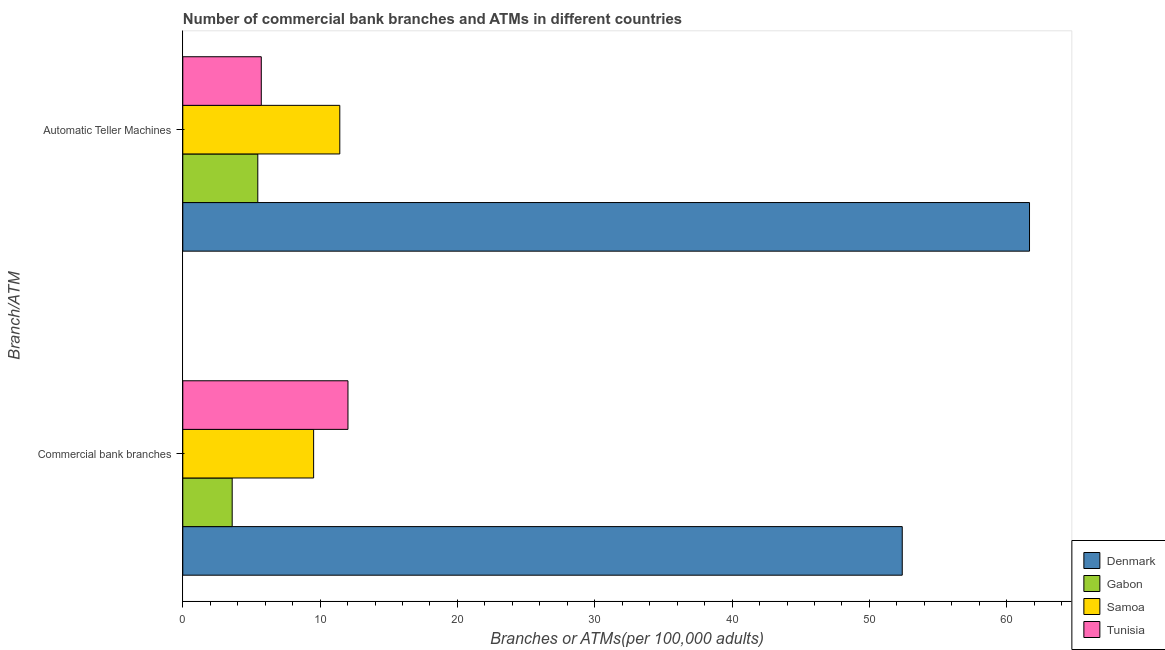How many groups of bars are there?
Provide a short and direct response. 2. How many bars are there on the 1st tick from the bottom?
Ensure brevity in your answer.  4. What is the label of the 1st group of bars from the top?
Your answer should be very brief. Automatic Teller Machines. What is the number of atms in Tunisia?
Your answer should be compact. 5.72. Across all countries, what is the maximum number of atms?
Ensure brevity in your answer.  61.66. Across all countries, what is the minimum number of commercal bank branches?
Provide a succinct answer. 3.6. In which country was the number of commercal bank branches maximum?
Ensure brevity in your answer.  Denmark. In which country was the number of atms minimum?
Offer a very short reply. Gabon. What is the total number of atms in the graph?
Your answer should be compact. 84.27. What is the difference between the number of commercal bank branches in Denmark and that in Samoa?
Provide a succinct answer. 42.86. What is the difference between the number of atms in Gabon and the number of commercal bank branches in Denmark?
Your answer should be compact. -46.93. What is the average number of atms per country?
Make the answer very short. 21.07. What is the difference between the number of atms and number of commercal bank branches in Denmark?
Offer a very short reply. 9.27. What is the ratio of the number of atms in Tunisia to that in Gabon?
Offer a very short reply. 1.05. Is the number of commercal bank branches in Tunisia less than that in Gabon?
Your answer should be very brief. No. What does the 1st bar from the bottom in Commercial bank branches represents?
Provide a succinct answer. Denmark. Are all the bars in the graph horizontal?
Ensure brevity in your answer.  Yes. How many countries are there in the graph?
Keep it short and to the point. 4. Where does the legend appear in the graph?
Ensure brevity in your answer.  Bottom right. How many legend labels are there?
Give a very brief answer. 4. What is the title of the graph?
Make the answer very short. Number of commercial bank branches and ATMs in different countries. What is the label or title of the X-axis?
Provide a short and direct response. Branches or ATMs(per 100,0 adults). What is the label or title of the Y-axis?
Provide a succinct answer. Branch/ATM. What is the Branches or ATMs(per 100,000 adults) in Denmark in Commercial bank branches?
Provide a succinct answer. 52.39. What is the Branches or ATMs(per 100,000 adults) in Gabon in Commercial bank branches?
Your response must be concise. 3.6. What is the Branches or ATMs(per 100,000 adults) of Samoa in Commercial bank branches?
Keep it short and to the point. 9.53. What is the Branches or ATMs(per 100,000 adults) in Tunisia in Commercial bank branches?
Your response must be concise. 12.03. What is the Branches or ATMs(per 100,000 adults) of Denmark in Automatic Teller Machines?
Your answer should be very brief. 61.66. What is the Branches or ATMs(per 100,000 adults) of Gabon in Automatic Teller Machines?
Give a very brief answer. 5.46. What is the Branches or ATMs(per 100,000 adults) in Samoa in Automatic Teller Machines?
Offer a terse response. 11.43. What is the Branches or ATMs(per 100,000 adults) in Tunisia in Automatic Teller Machines?
Ensure brevity in your answer.  5.72. Across all Branch/ATM, what is the maximum Branches or ATMs(per 100,000 adults) in Denmark?
Your response must be concise. 61.66. Across all Branch/ATM, what is the maximum Branches or ATMs(per 100,000 adults) in Gabon?
Offer a terse response. 5.46. Across all Branch/ATM, what is the maximum Branches or ATMs(per 100,000 adults) in Samoa?
Your response must be concise. 11.43. Across all Branch/ATM, what is the maximum Branches or ATMs(per 100,000 adults) in Tunisia?
Make the answer very short. 12.03. Across all Branch/ATM, what is the minimum Branches or ATMs(per 100,000 adults) of Denmark?
Make the answer very short. 52.39. Across all Branch/ATM, what is the minimum Branches or ATMs(per 100,000 adults) in Gabon?
Provide a succinct answer. 3.6. Across all Branch/ATM, what is the minimum Branches or ATMs(per 100,000 adults) in Samoa?
Keep it short and to the point. 9.53. Across all Branch/ATM, what is the minimum Branches or ATMs(per 100,000 adults) of Tunisia?
Provide a short and direct response. 5.72. What is the total Branches or ATMs(per 100,000 adults) in Denmark in the graph?
Keep it short and to the point. 114.05. What is the total Branches or ATMs(per 100,000 adults) of Gabon in the graph?
Make the answer very short. 9.06. What is the total Branches or ATMs(per 100,000 adults) in Samoa in the graph?
Offer a terse response. 20.96. What is the total Branches or ATMs(per 100,000 adults) in Tunisia in the graph?
Ensure brevity in your answer.  17.74. What is the difference between the Branches or ATMs(per 100,000 adults) of Denmark in Commercial bank branches and that in Automatic Teller Machines?
Keep it short and to the point. -9.27. What is the difference between the Branches or ATMs(per 100,000 adults) of Gabon in Commercial bank branches and that in Automatic Teller Machines?
Make the answer very short. -1.86. What is the difference between the Branches or ATMs(per 100,000 adults) in Samoa in Commercial bank branches and that in Automatic Teller Machines?
Offer a terse response. -1.91. What is the difference between the Branches or ATMs(per 100,000 adults) in Tunisia in Commercial bank branches and that in Automatic Teller Machines?
Provide a succinct answer. 6.31. What is the difference between the Branches or ATMs(per 100,000 adults) of Denmark in Commercial bank branches and the Branches or ATMs(per 100,000 adults) of Gabon in Automatic Teller Machines?
Ensure brevity in your answer.  46.93. What is the difference between the Branches or ATMs(per 100,000 adults) in Denmark in Commercial bank branches and the Branches or ATMs(per 100,000 adults) in Samoa in Automatic Teller Machines?
Ensure brevity in your answer.  40.96. What is the difference between the Branches or ATMs(per 100,000 adults) in Denmark in Commercial bank branches and the Branches or ATMs(per 100,000 adults) in Tunisia in Automatic Teller Machines?
Give a very brief answer. 46.68. What is the difference between the Branches or ATMs(per 100,000 adults) in Gabon in Commercial bank branches and the Branches or ATMs(per 100,000 adults) in Samoa in Automatic Teller Machines?
Provide a short and direct response. -7.84. What is the difference between the Branches or ATMs(per 100,000 adults) of Gabon in Commercial bank branches and the Branches or ATMs(per 100,000 adults) of Tunisia in Automatic Teller Machines?
Ensure brevity in your answer.  -2.12. What is the difference between the Branches or ATMs(per 100,000 adults) of Samoa in Commercial bank branches and the Branches or ATMs(per 100,000 adults) of Tunisia in Automatic Teller Machines?
Keep it short and to the point. 3.81. What is the average Branches or ATMs(per 100,000 adults) of Denmark per Branch/ATM?
Offer a very short reply. 57.02. What is the average Branches or ATMs(per 100,000 adults) in Gabon per Branch/ATM?
Provide a short and direct response. 4.53. What is the average Branches or ATMs(per 100,000 adults) in Samoa per Branch/ATM?
Offer a very short reply. 10.48. What is the average Branches or ATMs(per 100,000 adults) in Tunisia per Branch/ATM?
Your answer should be compact. 8.87. What is the difference between the Branches or ATMs(per 100,000 adults) in Denmark and Branches or ATMs(per 100,000 adults) in Gabon in Commercial bank branches?
Make the answer very short. 48.79. What is the difference between the Branches or ATMs(per 100,000 adults) in Denmark and Branches or ATMs(per 100,000 adults) in Samoa in Commercial bank branches?
Give a very brief answer. 42.86. What is the difference between the Branches or ATMs(per 100,000 adults) of Denmark and Branches or ATMs(per 100,000 adults) of Tunisia in Commercial bank branches?
Keep it short and to the point. 40.36. What is the difference between the Branches or ATMs(per 100,000 adults) of Gabon and Branches or ATMs(per 100,000 adults) of Samoa in Commercial bank branches?
Provide a short and direct response. -5.93. What is the difference between the Branches or ATMs(per 100,000 adults) of Gabon and Branches or ATMs(per 100,000 adults) of Tunisia in Commercial bank branches?
Your answer should be compact. -8.43. What is the difference between the Branches or ATMs(per 100,000 adults) in Samoa and Branches or ATMs(per 100,000 adults) in Tunisia in Commercial bank branches?
Offer a terse response. -2.5. What is the difference between the Branches or ATMs(per 100,000 adults) of Denmark and Branches or ATMs(per 100,000 adults) of Gabon in Automatic Teller Machines?
Offer a very short reply. 56.2. What is the difference between the Branches or ATMs(per 100,000 adults) in Denmark and Branches or ATMs(per 100,000 adults) in Samoa in Automatic Teller Machines?
Offer a terse response. 50.22. What is the difference between the Branches or ATMs(per 100,000 adults) of Denmark and Branches or ATMs(per 100,000 adults) of Tunisia in Automatic Teller Machines?
Make the answer very short. 55.94. What is the difference between the Branches or ATMs(per 100,000 adults) in Gabon and Branches or ATMs(per 100,000 adults) in Samoa in Automatic Teller Machines?
Your response must be concise. -5.97. What is the difference between the Branches or ATMs(per 100,000 adults) in Gabon and Branches or ATMs(per 100,000 adults) in Tunisia in Automatic Teller Machines?
Your response must be concise. -0.25. What is the difference between the Branches or ATMs(per 100,000 adults) in Samoa and Branches or ATMs(per 100,000 adults) in Tunisia in Automatic Teller Machines?
Ensure brevity in your answer.  5.72. What is the ratio of the Branches or ATMs(per 100,000 adults) in Denmark in Commercial bank branches to that in Automatic Teller Machines?
Offer a terse response. 0.85. What is the ratio of the Branches or ATMs(per 100,000 adults) of Gabon in Commercial bank branches to that in Automatic Teller Machines?
Give a very brief answer. 0.66. What is the ratio of the Branches or ATMs(per 100,000 adults) of Tunisia in Commercial bank branches to that in Automatic Teller Machines?
Ensure brevity in your answer.  2.1. What is the difference between the highest and the second highest Branches or ATMs(per 100,000 adults) of Denmark?
Make the answer very short. 9.27. What is the difference between the highest and the second highest Branches or ATMs(per 100,000 adults) in Gabon?
Make the answer very short. 1.86. What is the difference between the highest and the second highest Branches or ATMs(per 100,000 adults) in Samoa?
Ensure brevity in your answer.  1.91. What is the difference between the highest and the second highest Branches or ATMs(per 100,000 adults) of Tunisia?
Make the answer very short. 6.31. What is the difference between the highest and the lowest Branches or ATMs(per 100,000 adults) of Denmark?
Your answer should be compact. 9.27. What is the difference between the highest and the lowest Branches or ATMs(per 100,000 adults) in Gabon?
Provide a short and direct response. 1.86. What is the difference between the highest and the lowest Branches or ATMs(per 100,000 adults) of Samoa?
Keep it short and to the point. 1.91. What is the difference between the highest and the lowest Branches or ATMs(per 100,000 adults) of Tunisia?
Offer a very short reply. 6.31. 